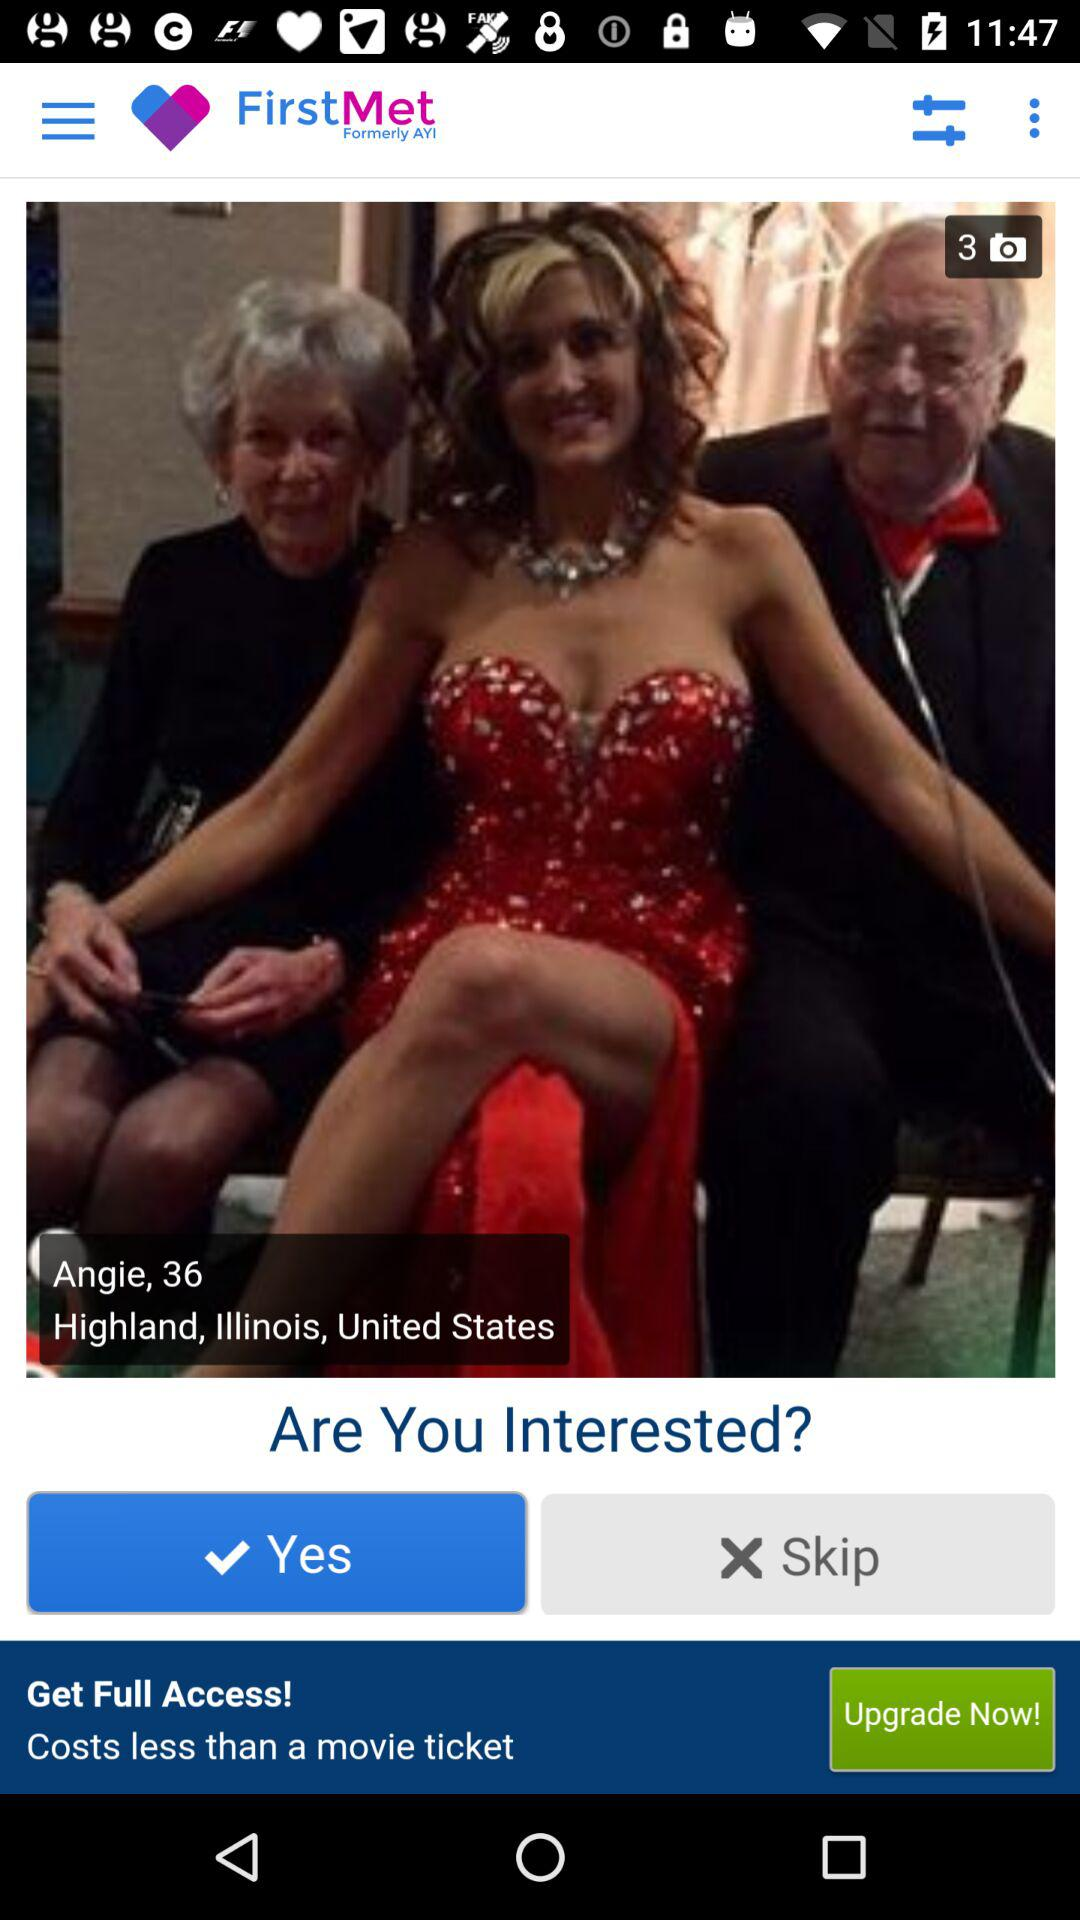What application is asking for permission? The application asking for permission is "FirstMet (formerly AYI)". 